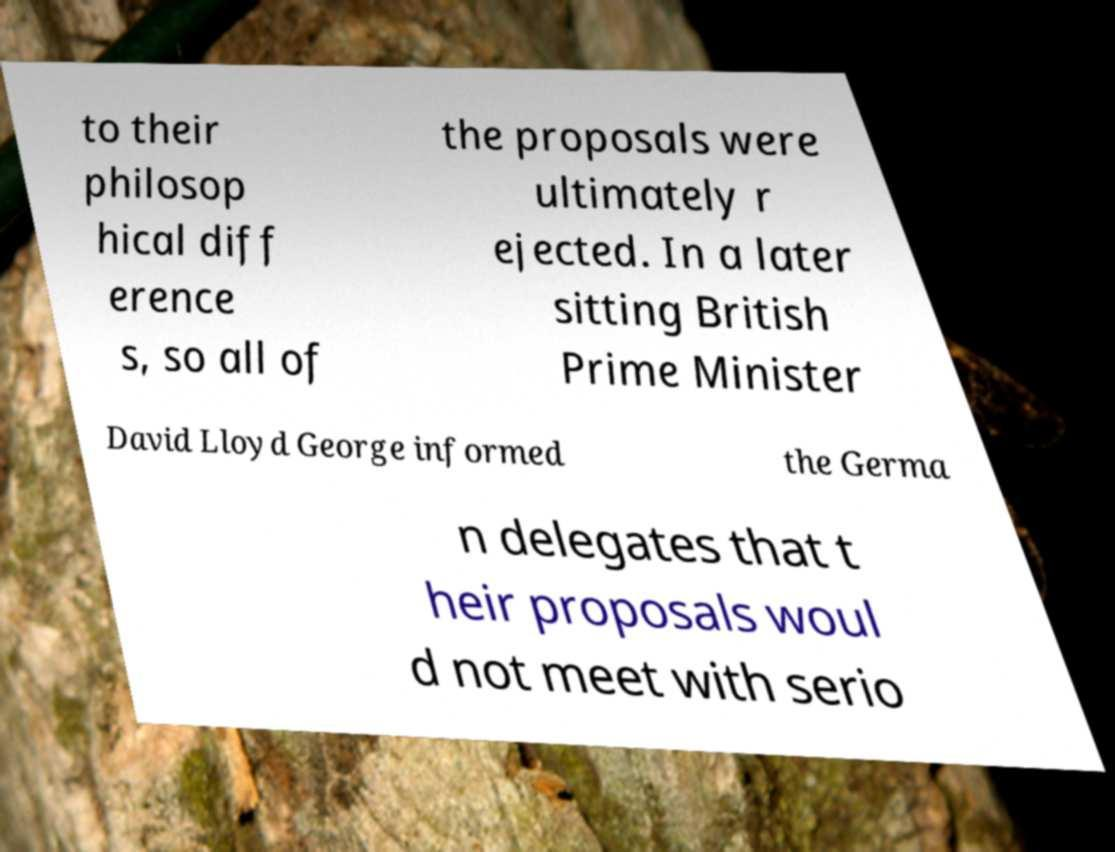Can you read and provide the text displayed in the image?This photo seems to have some interesting text. Can you extract and type it out for me? to their philosop hical diff erence s, so all of the proposals were ultimately r ejected. In a later sitting British Prime Minister David Lloyd George informed the Germa n delegates that t heir proposals woul d not meet with serio 